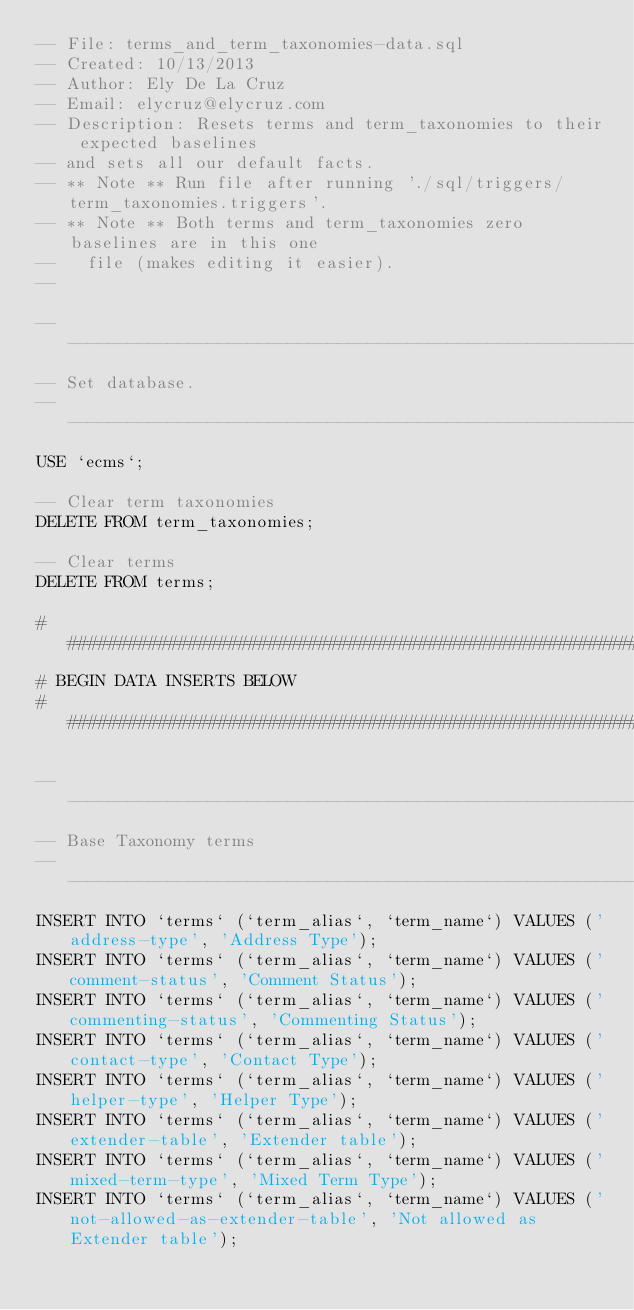<code> <loc_0><loc_0><loc_500><loc_500><_SQL_>-- File: terms_and_term_taxonomies-data.sql
-- Created: 10/13/2013
-- Author: Ely De La Cruz 
-- Email: elycruz@elycruz.com
-- Description: Resets terms and term_taxonomies to their expected baselines 
-- and sets all our default facts.
-- ** Note ** Run file after running './sql/triggers/term_taxonomies.triggers'.
-- ** Note ** Both terms and term_taxonomies zero baselines are in this one
--   file (makes editing it easier).
-- 

-- ----------------------------------------------------------------------------
-- Set database.
-- ----------------------------------------------------------------------------
USE `ecms`;

-- Clear term taxonomies
DELETE FROM term_taxonomies;

-- Clear terms
DELETE FROM terms;

# #############################################################################
# BEGIN DATA INSERTS BELOW 
# #############################################################################

-- ----------------------------------------------------------------------------
-- Base Taxonomy terms
-- ----------------------------------------------------------------------------
INSERT INTO `terms` (`term_alias`, `term_name`) VALUES ('address-type', 'Address Type');
INSERT INTO `terms` (`term_alias`, `term_name`) VALUES ('comment-status', 'Comment Status');
INSERT INTO `terms` (`term_alias`, `term_name`) VALUES ('commenting-status', 'Commenting Status');
INSERT INTO `terms` (`term_alias`, `term_name`) VALUES ('contact-type', 'Contact Type');
INSERT INTO `terms` (`term_alias`, `term_name`) VALUES ('helper-type', 'Helper Type');
INSERT INTO `terms` (`term_alias`, `term_name`) VALUES ('extender-table', 'Extender table');
INSERT INTO `terms` (`term_alias`, `term_name`) VALUES ('mixed-term-type', 'Mixed Term Type');
INSERT INTO `terms` (`term_alias`, `term_name`) VALUES ('not-allowed-as-extender-table', 'Not allowed as Extender table');</code> 